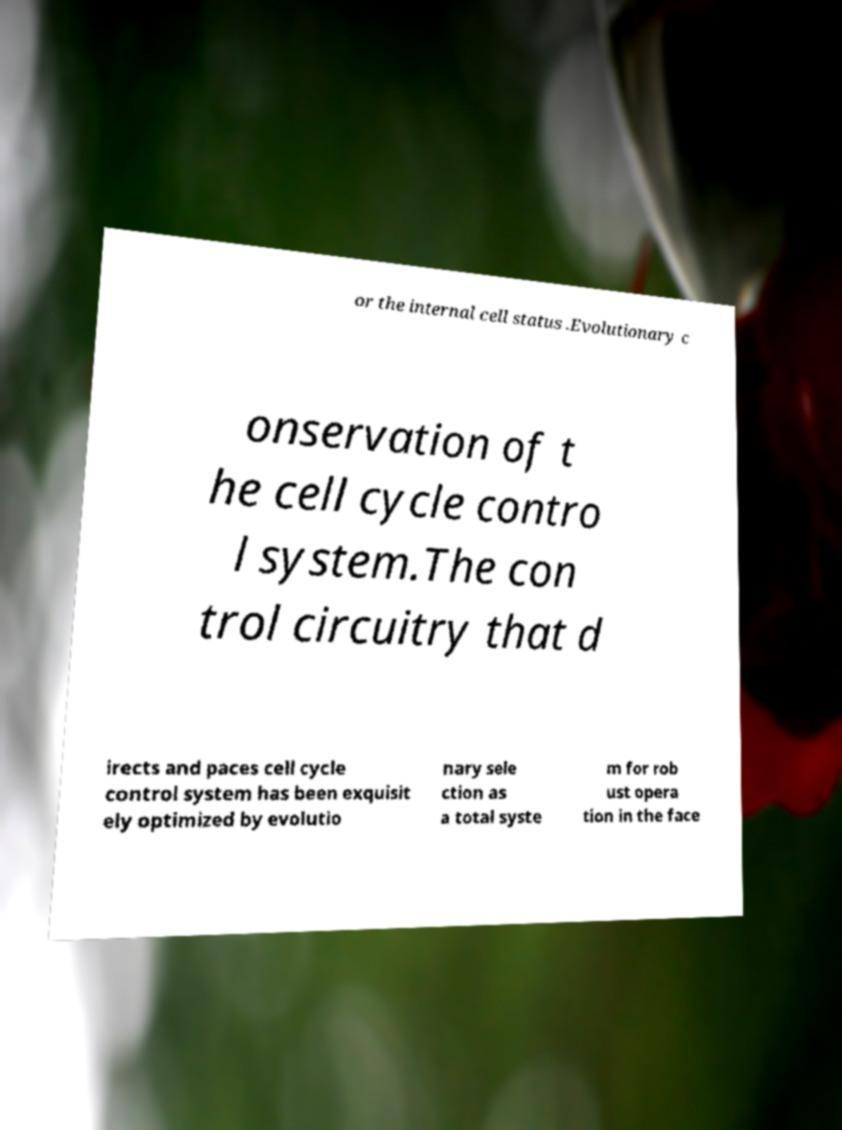Can you read and provide the text displayed in the image?This photo seems to have some interesting text. Can you extract and type it out for me? or the internal cell status .Evolutionary c onservation of t he cell cycle contro l system.The con trol circuitry that d irects and paces cell cycle control system has been exquisit ely optimized by evolutio nary sele ction as a total syste m for rob ust opera tion in the face 